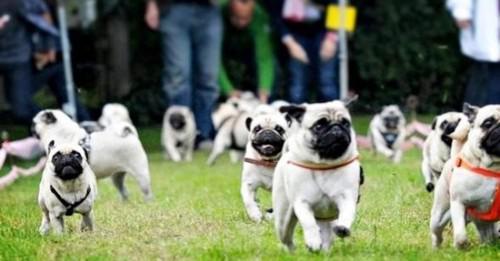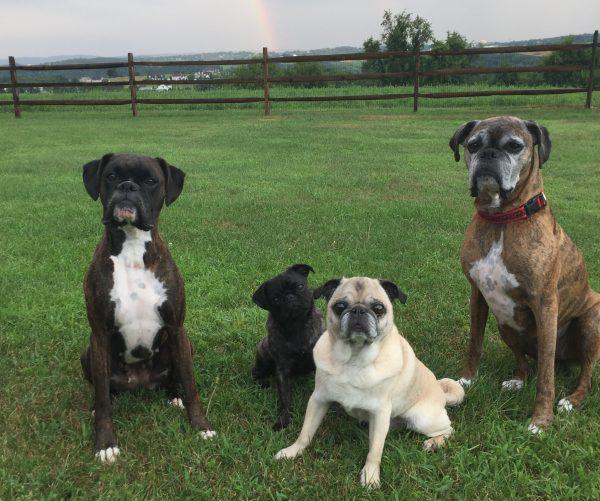The first image is the image on the left, the second image is the image on the right. For the images displayed, is the sentence "At least one image shows a group of pugs running toward the camera on grass." factually correct? Answer yes or no. Yes. The first image is the image on the left, the second image is the image on the right. Considering the images on both sides, is "People are seen with the dogs on the left." valid? Answer yes or no. Yes. 